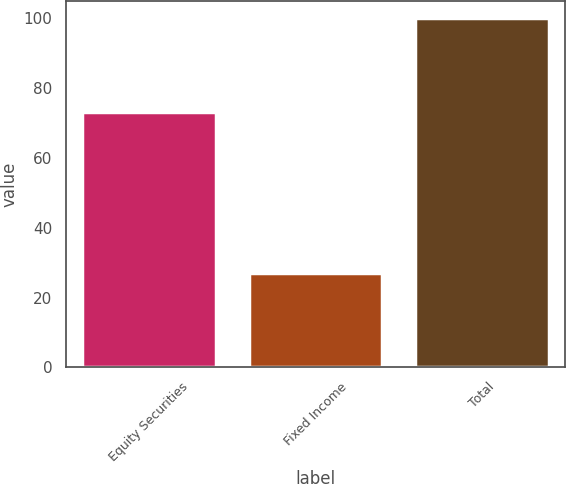Convert chart. <chart><loc_0><loc_0><loc_500><loc_500><bar_chart><fcel>Equity Securities<fcel>Fixed Income<fcel>Total<nl><fcel>73<fcel>27<fcel>100<nl></chart> 